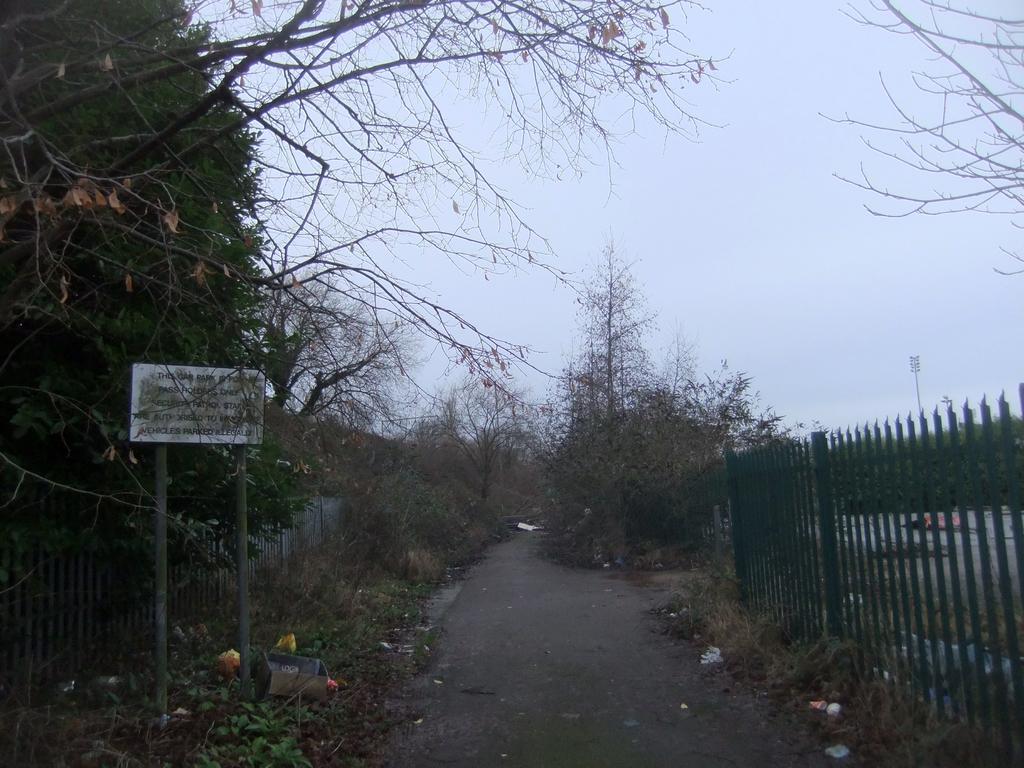How would you summarize this image in a sentence or two? In the background we can see the sky. In this picture we can see a board, poles, railings, road, branches, objects, dried leaves and trees. 